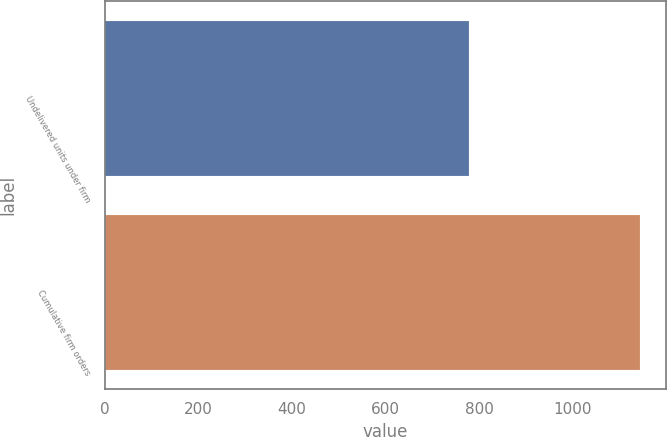Convert chart. <chart><loc_0><loc_0><loc_500><loc_500><bar_chart><fcel>Undelivered units under firm<fcel>Cumulative firm orders<nl><fcel>779<fcel>1142<nl></chart> 